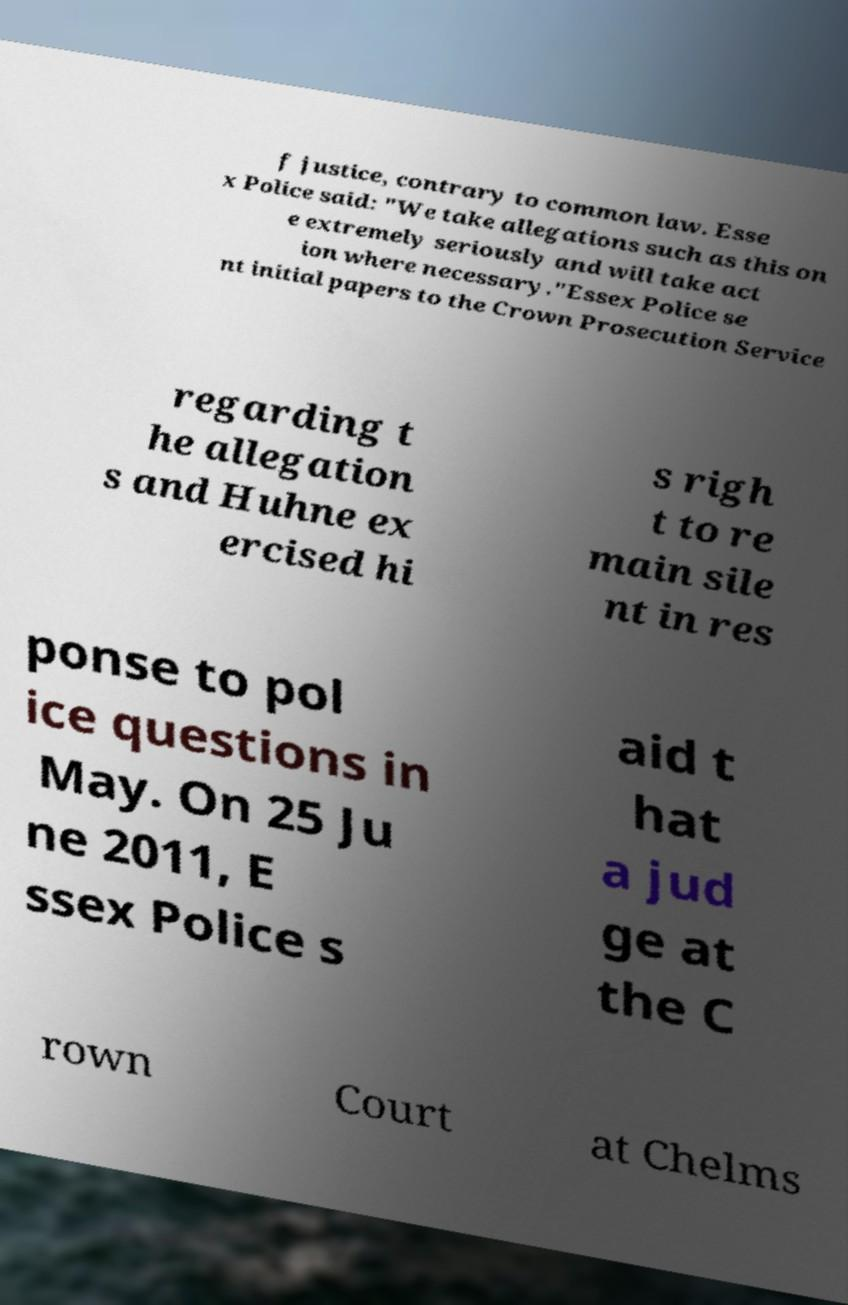Please read and relay the text visible in this image. What does it say? f justice, contrary to common law. Esse x Police said: "We take allegations such as this on e extremely seriously and will take act ion where necessary."Essex Police se nt initial papers to the Crown Prosecution Service regarding t he allegation s and Huhne ex ercised hi s righ t to re main sile nt in res ponse to pol ice questions in May. On 25 Ju ne 2011, E ssex Police s aid t hat a jud ge at the C rown Court at Chelms 